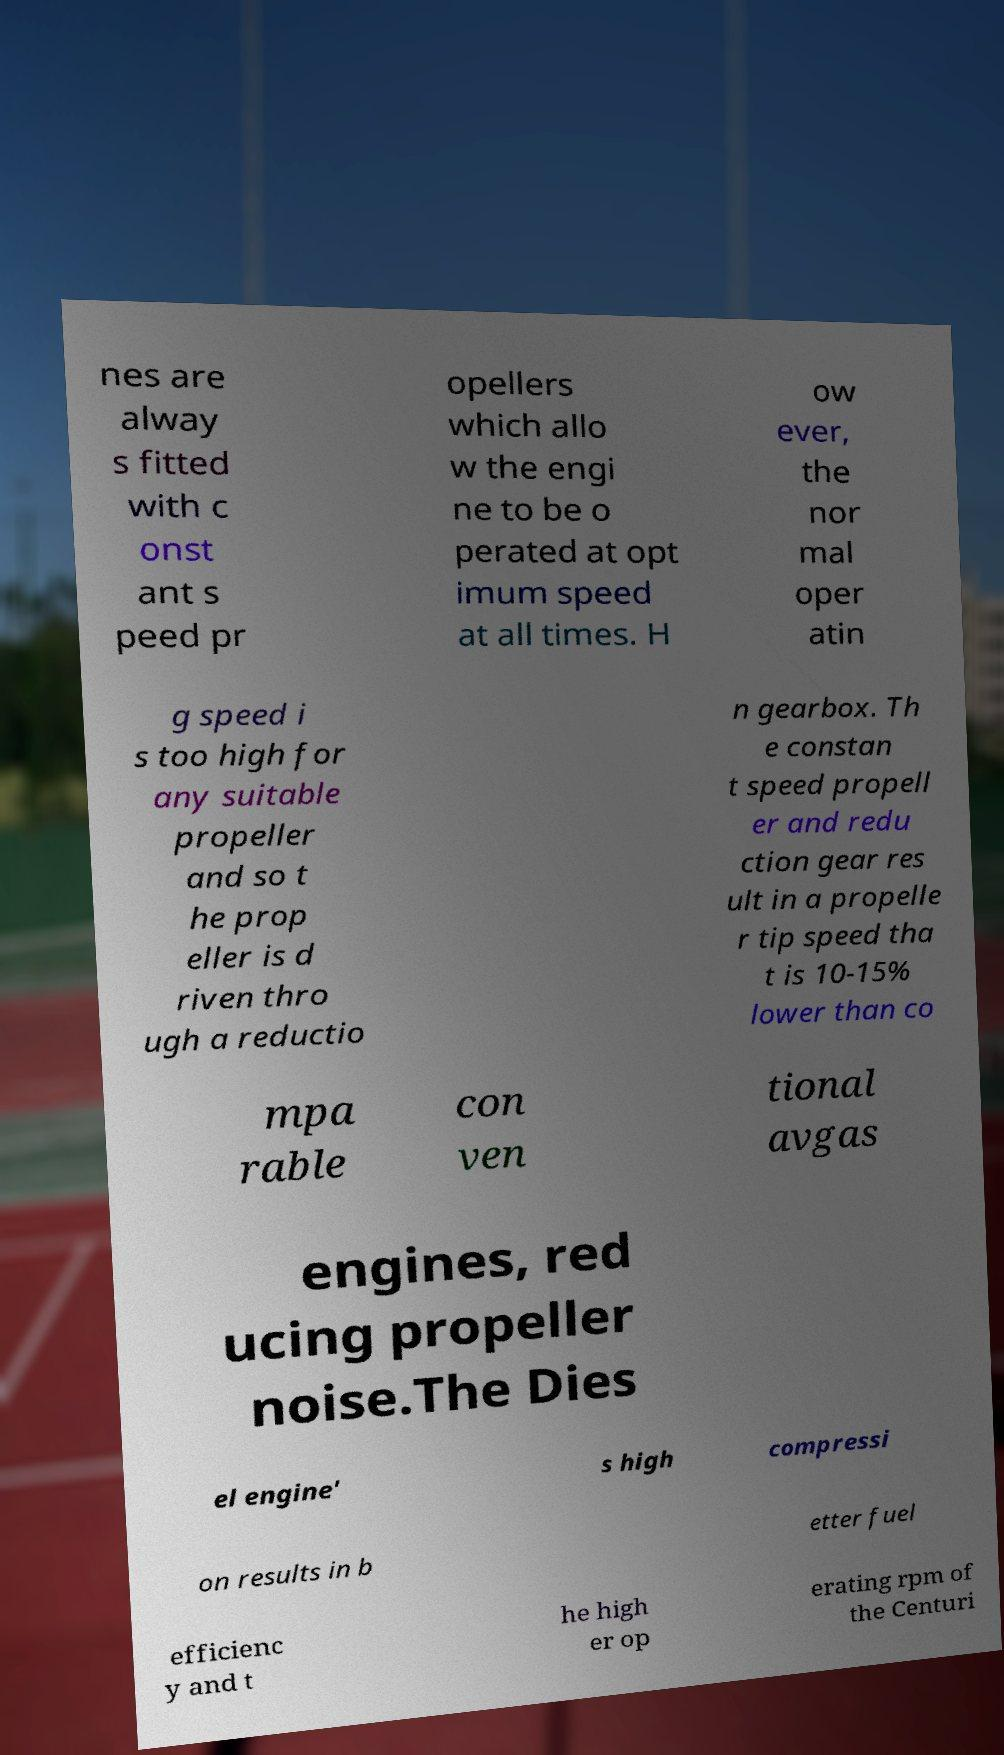Please identify and transcribe the text found in this image. nes are alway s fitted with c onst ant s peed pr opellers which allo w the engi ne to be o perated at opt imum speed at all times. H ow ever, the nor mal oper atin g speed i s too high for any suitable propeller and so t he prop eller is d riven thro ugh a reductio n gearbox. Th e constan t speed propell er and redu ction gear res ult in a propelle r tip speed tha t is 10-15% lower than co mpa rable con ven tional avgas engines, red ucing propeller noise.The Dies el engine' s high compressi on results in b etter fuel efficienc y and t he high er op erating rpm of the Centuri 